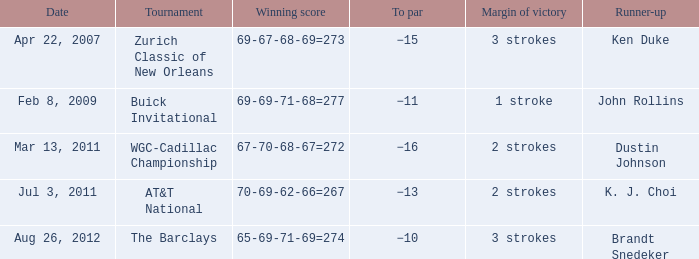Who finished second in the contest with a 2-stroke victory margin and a to par of -16? Dustin Johnson. 